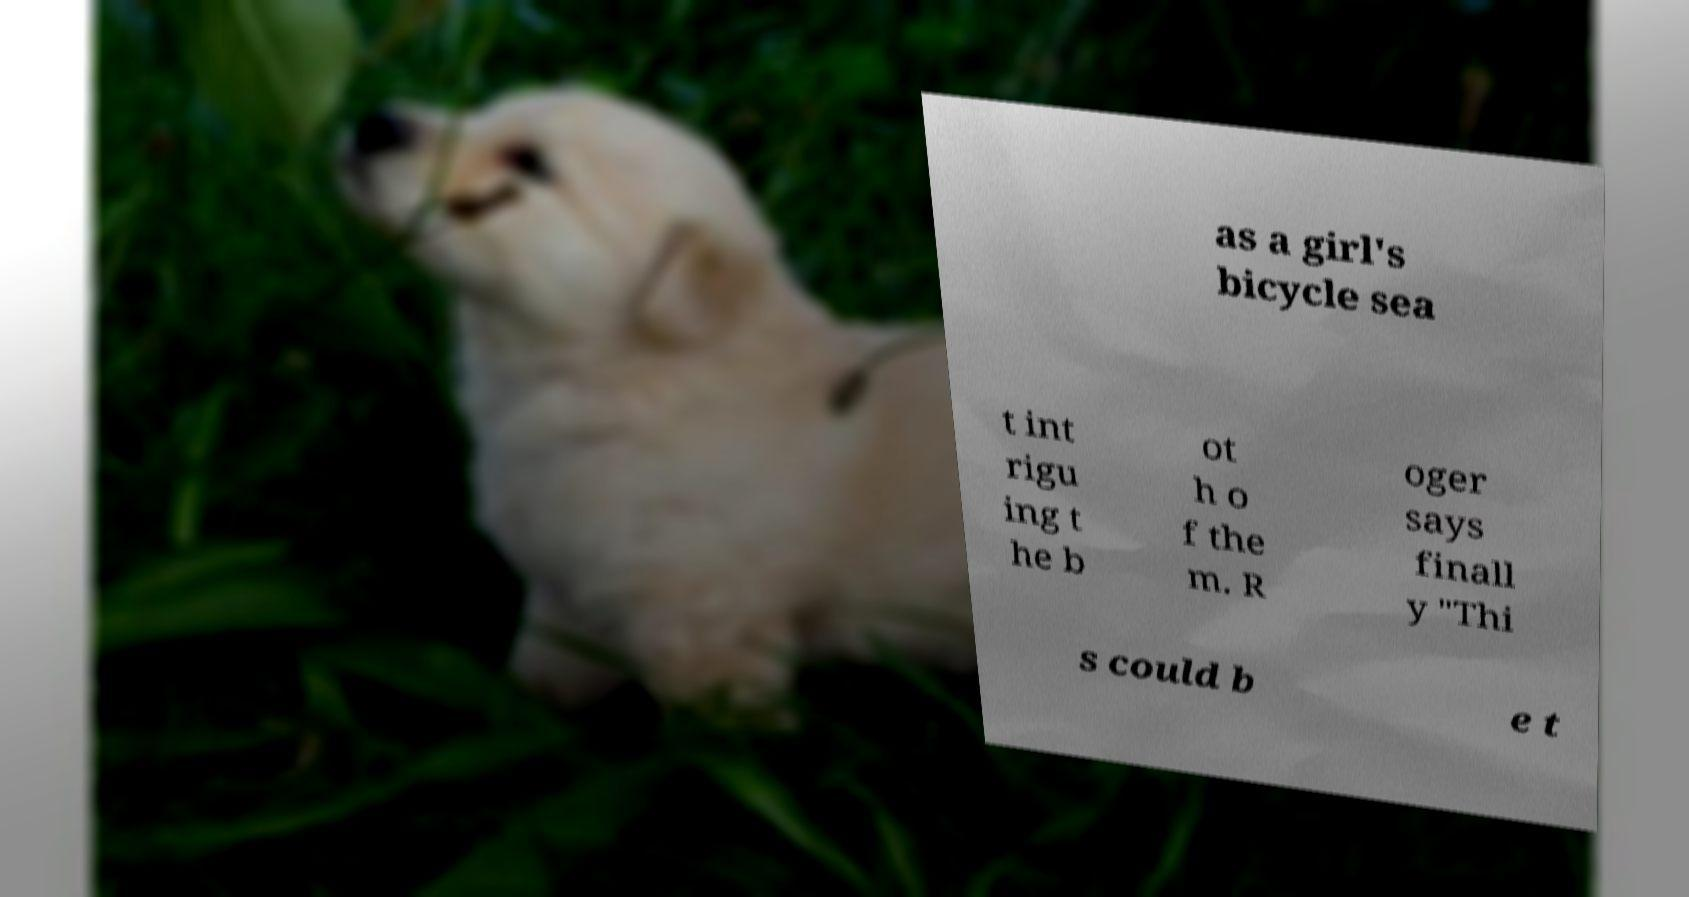For documentation purposes, I need the text within this image transcribed. Could you provide that? as a girl's bicycle sea t int rigu ing t he b ot h o f the m. R oger says finall y "Thi s could b e t 